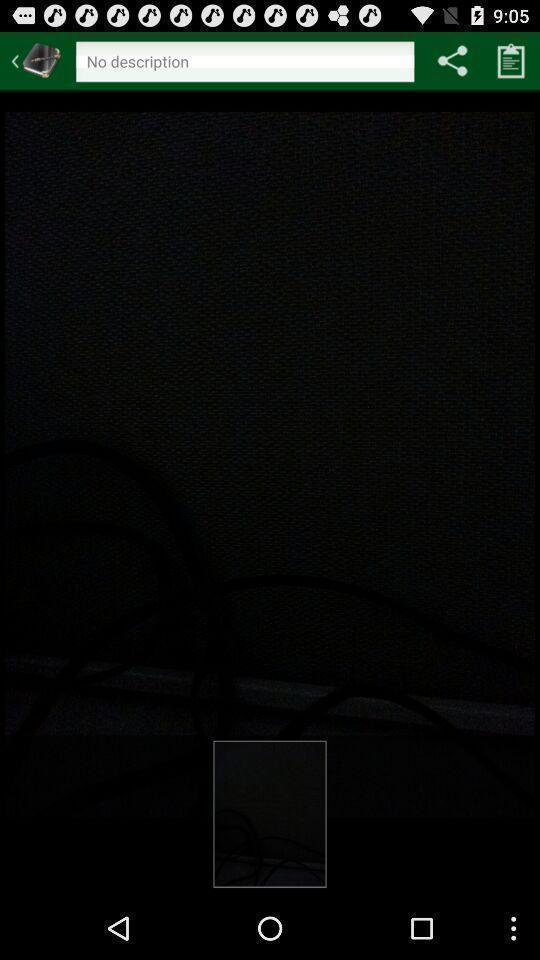Describe the key features of this screenshot. Page showing no description in search bar option for app. 